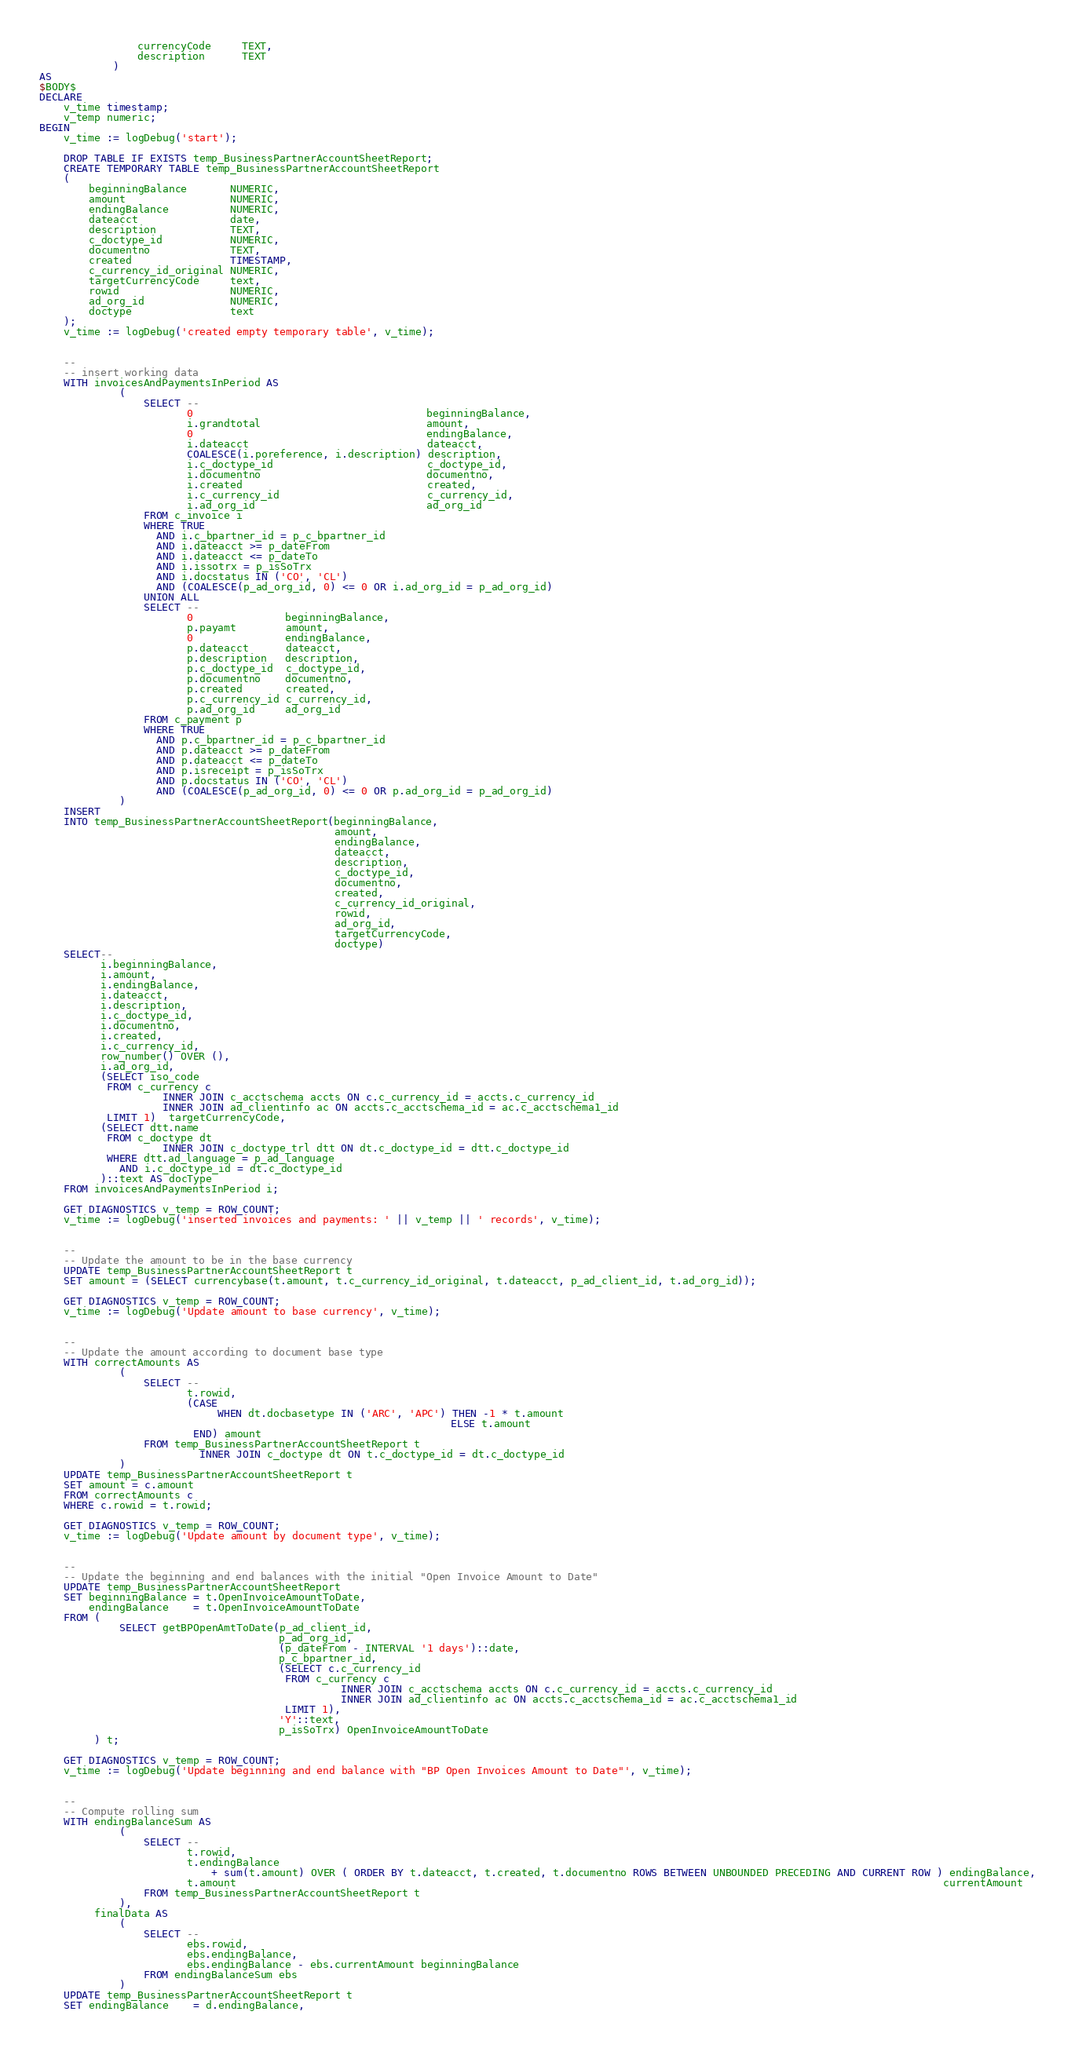Convert code to text. <code><loc_0><loc_0><loc_500><loc_500><_SQL_>                currencyCode     TEXT,
                description      TEXT
            )
AS
$BODY$
DECLARE
    v_time timestamp;
    v_temp numeric;
BEGIN
    v_time := logDebug('start');

    DROP TABLE IF EXISTS temp_BusinessPartnerAccountSheetReport;
    CREATE TEMPORARY TABLE temp_BusinessPartnerAccountSheetReport
    (
        beginningBalance       NUMERIC,
        amount                 NUMERIC,
        endingBalance          NUMERIC,
        dateacct               date,
        description            TEXT,
        c_doctype_id           NUMERIC,
        documentno             TEXT,
        created                TIMESTAMP,
        c_currency_id_original NUMERIC,
        targetCurrencyCode     text,
        rowid                  NUMERIC,
        ad_org_id              NUMERIC,
        doctype                text
    );
    v_time := logDebug('created empty temporary table', v_time);


    --
    -- insert working data
    WITH invoicesAndPaymentsInPeriod AS
             (
                 SELECT --
                        0                                      beginningBalance,
                        i.grandtotal                           amount,
                        0                                      endingBalance,
                        i.dateacct                             dateacct,
                        COALESCE(i.poreference, i.description) description,
                        i.c_doctype_id                         c_doctype_id,
                        i.documentno                           documentno,
                        i.created                              created,
                        i.c_currency_id                        c_currency_id,
                        i.ad_org_id                            ad_org_id
                 FROM c_invoice i
                 WHERE TRUE
                   AND i.c_bpartner_id = p_c_bpartner_id
                   AND i.dateacct >= p_dateFrom
                   AND i.dateacct <= p_dateTo
                   AND i.issotrx = p_isSoTrx
                   AND i.docstatus IN ('CO', 'CL')
                   AND (COALESCE(p_ad_org_id, 0) <= 0 OR i.ad_org_id = p_ad_org_id)
                 UNION ALL
                 SELECT --
                        0               beginningBalance,
                        p.payamt        amount,
                        0               endingBalance,
                        p.dateacct      dateacct,
                        p.description   description,
                        p.c_doctype_id  c_doctype_id,
                        p.documentno    documentno,
                        p.created       created,
                        p.c_currency_id c_currency_id,
                        p.ad_org_id     ad_org_id
                 FROM c_payment p
                 WHERE TRUE
                   AND p.c_bpartner_id = p_c_bpartner_id
                   AND p.dateacct >= p_dateFrom
                   AND p.dateacct <= p_dateTo
                   AND p.isreceipt = p_isSoTrx
                   AND p.docstatus IN ('CO', 'CL')
                   AND (COALESCE(p_ad_org_id, 0) <= 0 OR p.ad_org_id = p_ad_org_id)
             )
    INSERT
    INTO temp_BusinessPartnerAccountSheetReport(beginningBalance,
                                                amount,
                                                endingBalance,
                                                dateacct,
                                                description,
                                                c_doctype_id,
                                                documentno,
                                                created,
                                                c_currency_id_original,
                                                rowid,
                                                ad_org_id,
                                                targetCurrencyCode,
                                                doctype)
    SELECT--
          i.beginningBalance,
          i.amount,
          i.endingBalance,
          i.dateacct,
          i.description,
          i.c_doctype_id,
          i.documentno,
          i.created,
          i.c_currency_id,
          row_number() OVER (),
          i.ad_org_id,
          (SELECT iso_code
           FROM c_currency c
                    INNER JOIN c_acctschema accts ON c.c_currency_id = accts.c_currency_id
                    INNER JOIN ad_clientinfo ac ON accts.c_acctschema_id = ac.c_acctschema1_id
           LIMIT 1)  targetCurrencyCode,
          (SELECT dtt.name
           FROM c_doctype dt
                    INNER JOIN c_doctype_trl dtt ON dt.c_doctype_id = dtt.c_doctype_id
           WHERE dtt.ad_language = p_ad_language
             AND i.c_doctype_id = dt.c_doctype_id
          )::text AS docType
    FROM invoicesAndPaymentsInPeriod i;

    GET DIAGNOSTICS v_temp = ROW_COUNT;
    v_time := logDebug('inserted invoices and payments: ' || v_temp || ' records', v_time);


    --
    -- Update the amount to be in the base currency
    UPDATE temp_BusinessPartnerAccountSheetReport t
    SET amount = (SELECT currencybase(t.amount, t.c_currency_id_original, t.dateacct, p_ad_client_id, t.ad_org_id));

    GET DIAGNOSTICS v_temp = ROW_COUNT;
    v_time := logDebug('Update amount to base currency', v_time);


    --
    -- Update the amount according to document base type
    WITH correctAmounts AS
             (
                 SELECT --
                        t.rowid,
                        (CASE
                             WHEN dt.docbasetype IN ('ARC', 'APC') THEN -1 * t.amount
                                                                   ELSE t.amount
                         END) amount
                 FROM temp_BusinessPartnerAccountSheetReport t
                          INNER JOIN c_doctype dt ON t.c_doctype_id = dt.c_doctype_id
             )
    UPDATE temp_BusinessPartnerAccountSheetReport t
    SET amount = c.amount
    FROM correctAmounts c
    WHERE c.rowid = t.rowid;

    GET DIAGNOSTICS v_temp = ROW_COUNT;
    v_time := logDebug('Update amount by document type', v_time);


    --
    -- Update the beginning and end balances with the initial "Open Invoice Amount to Date"
    UPDATE temp_BusinessPartnerAccountSheetReport
    SET beginningBalance = t.OpenInvoiceAmountToDate,
        endingBalance    = t.OpenInvoiceAmountToDate
    FROM (
             SELECT getBPOpenAmtToDate(p_ad_client_id,
                                       p_ad_org_id,
                                       (p_dateFrom - INTERVAL '1 days')::date,
                                       p_c_bpartner_id,
                                       (SELECT c.c_currency_id
                                        FROM c_currency c
                                                 INNER JOIN c_acctschema accts ON c.c_currency_id = accts.c_currency_id
                                                 INNER JOIN ad_clientinfo ac ON accts.c_acctschema_id = ac.c_acctschema1_id
                                        LIMIT 1),
                                       'Y'::text,
                                       p_isSoTrx) OpenInvoiceAmountToDate
         ) t;

    GET DIAGNOSTICS v_temp = ROW_COUNT;
    v_time := logDebug('Update beginning and end balance with "BP Open Invoices Amount to Date"', v_time);


    --
    -- Compute rolling sum
    WITH endingBalanceSum AS
             (
                 SELECT --
                        t.rowid,
                        t.endingBalance
                            + sum(t.amount) OVER ( ORDER BY t.dateacct, t.created, t.documentno ROWS BETWEEN UNBOUNDED PRECEDING AND CURRENT ROW ) endingBalance,
                        t.amount                                                                                                                   currentAmount
                 FROM temp_BusinessPartnerAccountSheetReport t
             ),
         finalData AS
             (
                 SELECT --
                        ebs.rowid,
                        ebs.endingBalance,
                        ebs.endingBalance - ebs.currentAmount beginningBalance
                 FROM endingBalanceSum ebs
             )
    UPDATE temp_BusinessPartnerAccountSheetReport t
    SET endingBalance    = d.endingBalance,</code> 